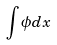<formula> <loc_0><loc_0><loc_500><loc_500>\int \phi d x</formula> 